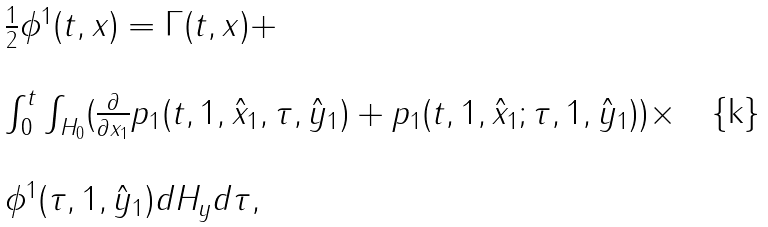Convert formula to latex. <formula><loc_0><loc_0><loc_500><loc_500>\begin{array} { l l } \frac { 1 } { 2 } \phi ^ { 1 } ( t , x ) = \Gamma ( t , x ) + \\ \\ \int _ { 0 } ^ { t } \int _ { H _ { 0 } } ( \frac { \partial } { \partial x _ { 1 } } p _ { 1 } ( t , 1 , \hat { x } _ { 1 } , \tau , \hat { y } _ { 1 } ) + p _ { 1 } ( t , 1 , \hat { x } _ { 1 } ; \tau , 1 , \hat { y } _ { 1 } ) ) \times \\ \\ \phi ^ { 1 } ( \tau , 1 , \hat { y } _ { 1 } ) d H _ { y } d \tau , \end{array}</formula> 